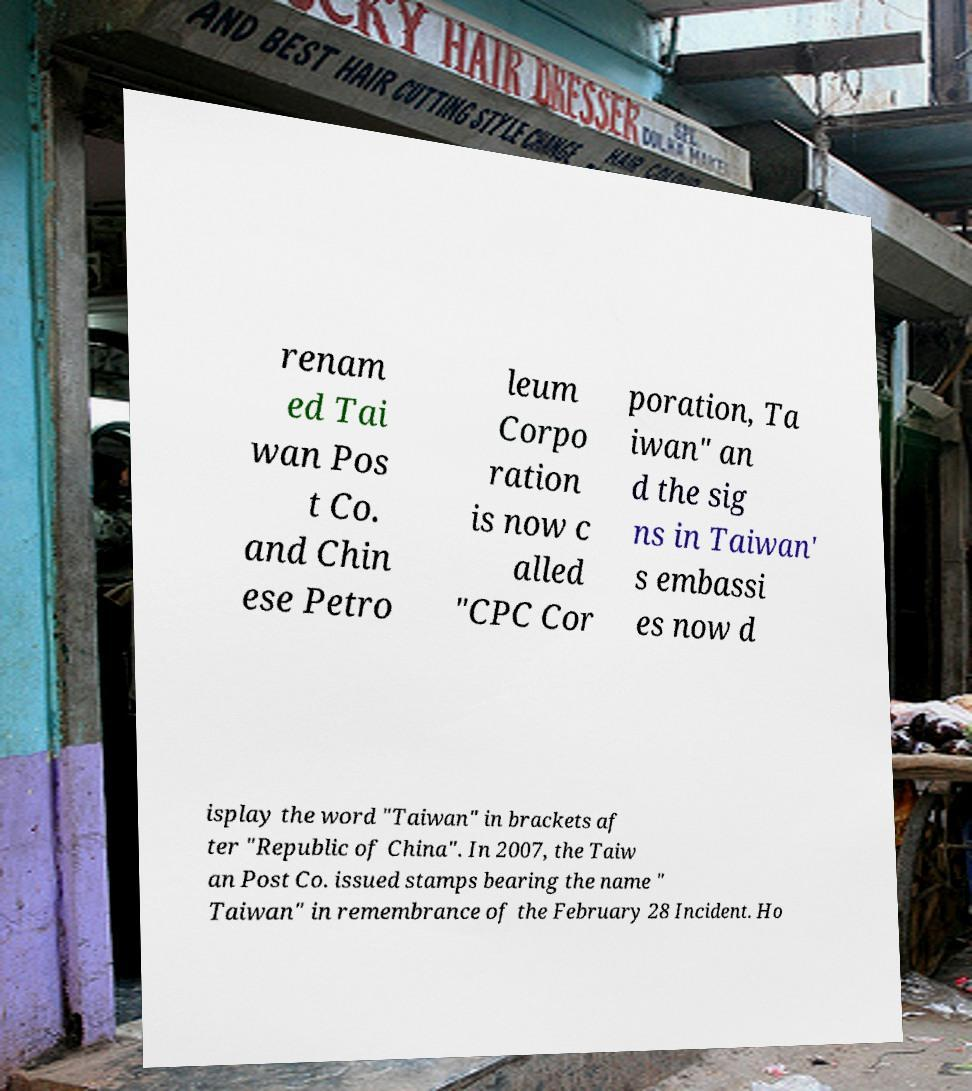There's text embedded in this image that I need extracted. Can you transcribe it verbatim? renam ed Tai wan Pos t Co. and Chin ese Petro leum Corpo ration is now c alled "CPC Cor poration, Ta iwan" an d the sig ns in Taiwan' s embassi es now d isplay the word "Taiwan" in brackets af ter "Republic of China". In 2007, the Taiw an Post Co. issued stamps bearing the name " Taiwan" in remembrance of the February 28 Incident. Ho 